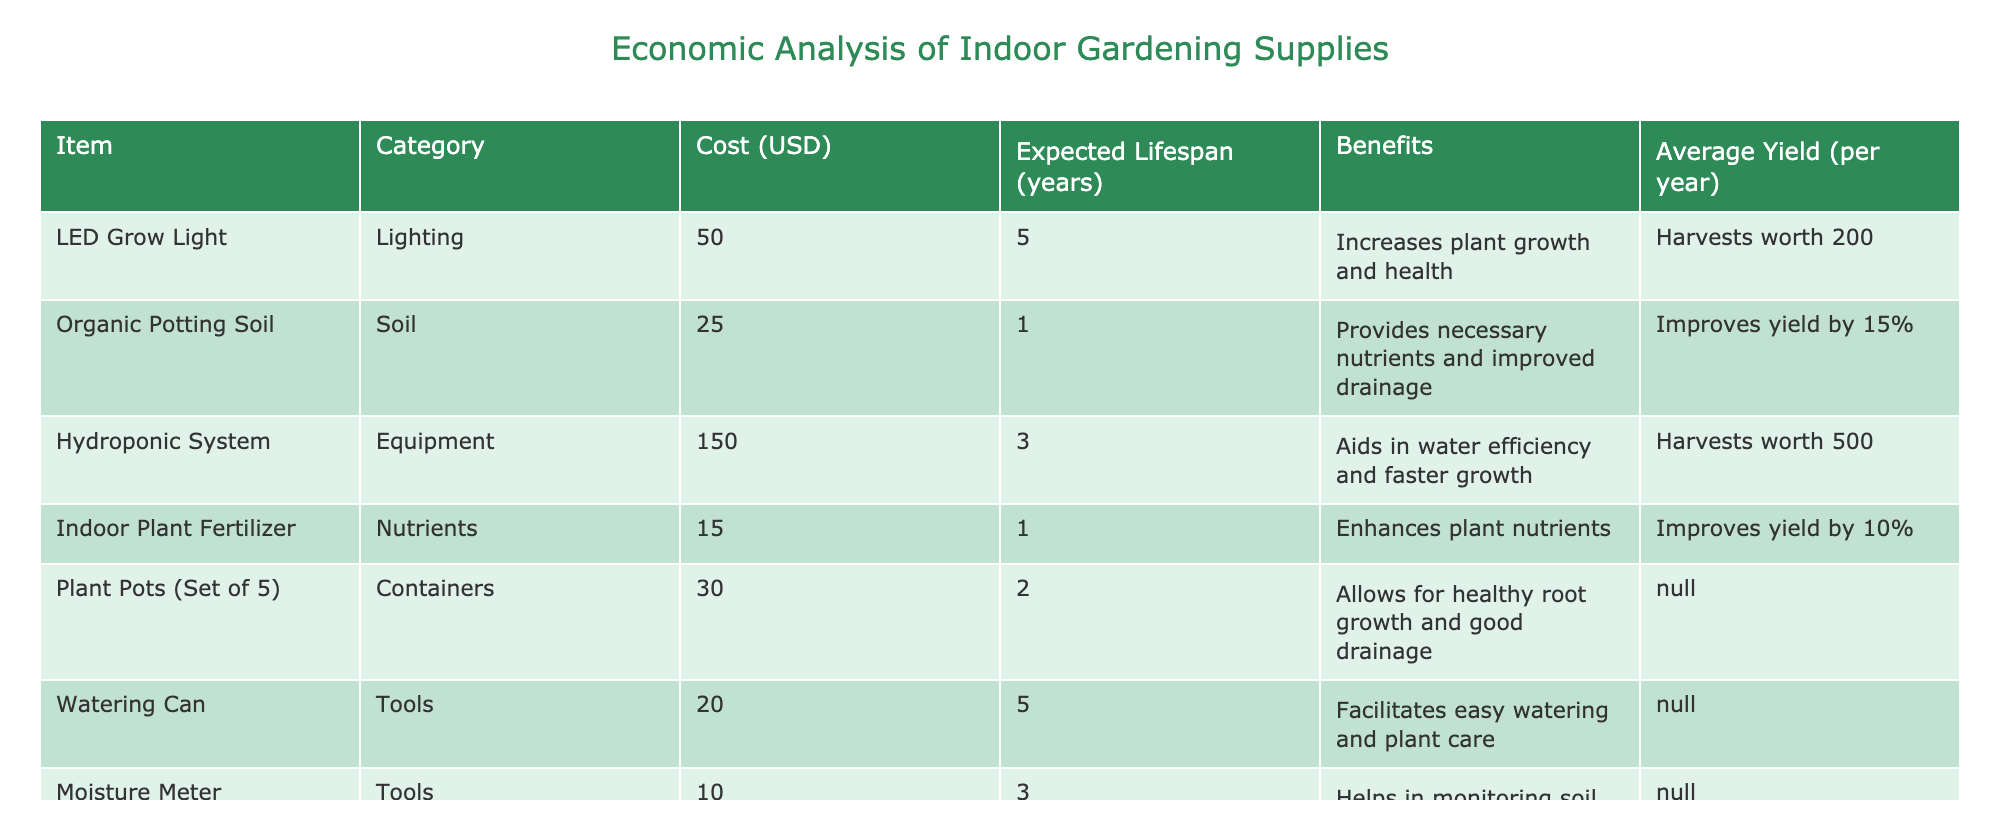What is the cost of the Hydroponic System? The table lists the Hydroponic System under the Equipment category, showing a cost of 150 USD.
Answer: 150 USD What benefit does Organic Potting Soil provide? According to the table, Organic Potting Soil provides necessary nutrients and improved drainage as a benefit.
Answer: Provides necessary nutrients and improved drainage How much does the Indoor Plant Schedule App cost? The cost associated with the Indoor Plant Schedule App listed in the table is 5 USD.
Answer: 5 USD What is the expected lifespan of the LED Grow Light? The expected lifespan of the LED Grow Light, as indicated in the table, is 5 years.
Answer: 5 years What is the average yield from using the Hydroponic System? The table states that the average yield from the Hydroponic System is worth 500 USD per year.
Answer: 500 USD Is the Indoor Plant Fertilizer expected to improve yield? Yes, the table shows that Indoor Plant Fertilizer improves yield by 10%.
Answer: Yes Which item has the highest expected yield? To determine this, we compare the average yield of all items: Hydroponic System (500), LED Grow Light (200), and others with improvements in yield by percentage. The Hydroponic System has the highest yield of 500 USD.
Answer: Hydroponic System What is the total cost of all items listed in the table? To find the total cost, we sum the costs of each item: 50 + 25 + 150 + 15 + 30 + 20 + 10 + 5 = 305 USD. Therefore, the total cost of all listed items is 305 USD.
Answer: 305 USD How many items expect to last 3 years or more? From a review of the data, the LED Grow Light and the Watering Can have a lifespan of 5 years, while the Hydroponic System has a lifespan of 3 years. Thus, there are 3 items that last 3 years or more.
Answer: 3 items 